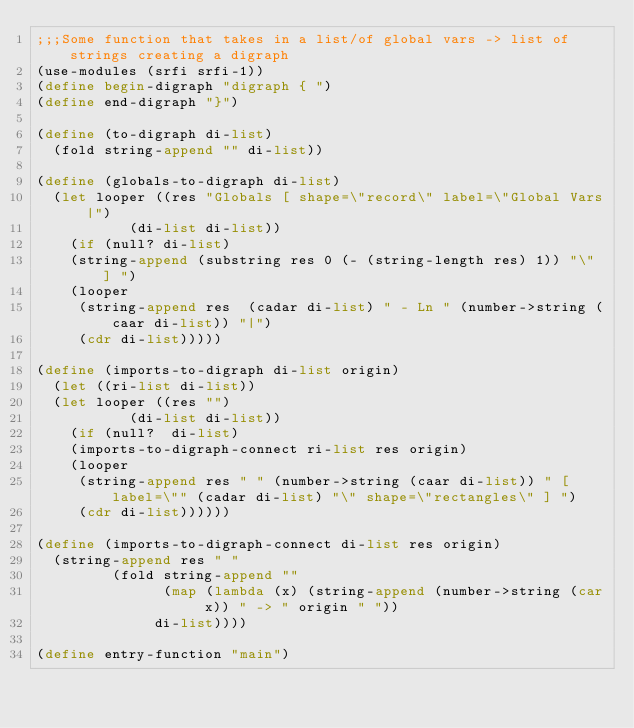Convert code to text. <code><loc_0><loc_0><loc_500><loc_500><_Scheme_>;;;Some function that takes in a list/of global vars -> list of strings creating a digraph
(use-modules (srfi srfi-1))
(define begin-digraph "digraph { ")
(define end-digraph "}")

(define (to-digraph di-list)
  (fold string-append "" di-list))

(define (globals-to-digraph di-list)
  (let looper ((res "Globals [ shape=\"record\" label=\"Global Vars|")
	       (di-list di-list))
    (if (null? di-list)
	(string-append (substring res 0 (- (string-length res) 1)) "\" ] ")
	(looper
	 (string-append res  (cadar di-list) " - Ln " (number->string (caar di-list)) "|")
	 (cdr di-list)))))

(define (imports-to-digraph di-list origin)
  (let ((ri-list di-list))
  (let looper ((res "")
	       (di-list di-list))
    (if (null?  di-list)
	(imports-to-digraph-connect ri-list res origin)
	(looper
	 (string-append res " " (number->string (caar di-list)) " [ label=\"" (cadar di-list) "\" shape=\"rectangles\" ] ")
	 (cdr di-list))))))

(define (imports-to-digraph-connect di-list res origin)
  (string-append res " "
		 (fold string-append ""
		       (map (lambda (x) (string-append (number->string (car x)) " -> " origin " "))
		      di-list))))
	       
(define entry-function "main")


</code> 